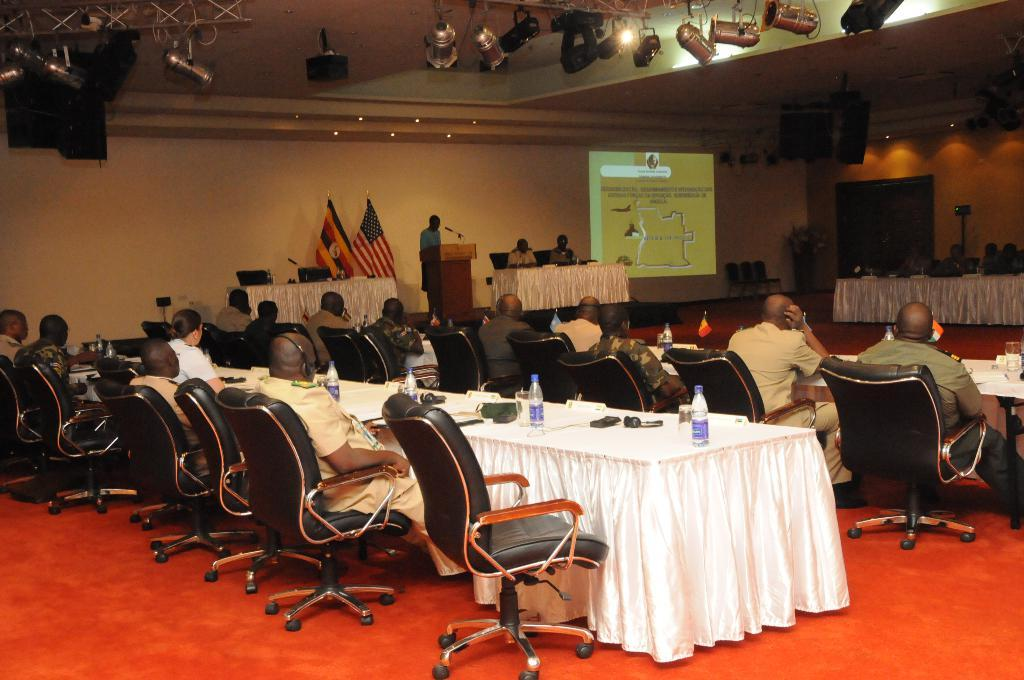What are the people in the image doing? The people in the image are sitting on chairs. Can you describe the man in the image? There is a man standing in front of a podium in the image. What appliance is the man using to express his hate in the image? There is no appliance or expression of hate present in the image. The man is simply standing in front of a podium. 